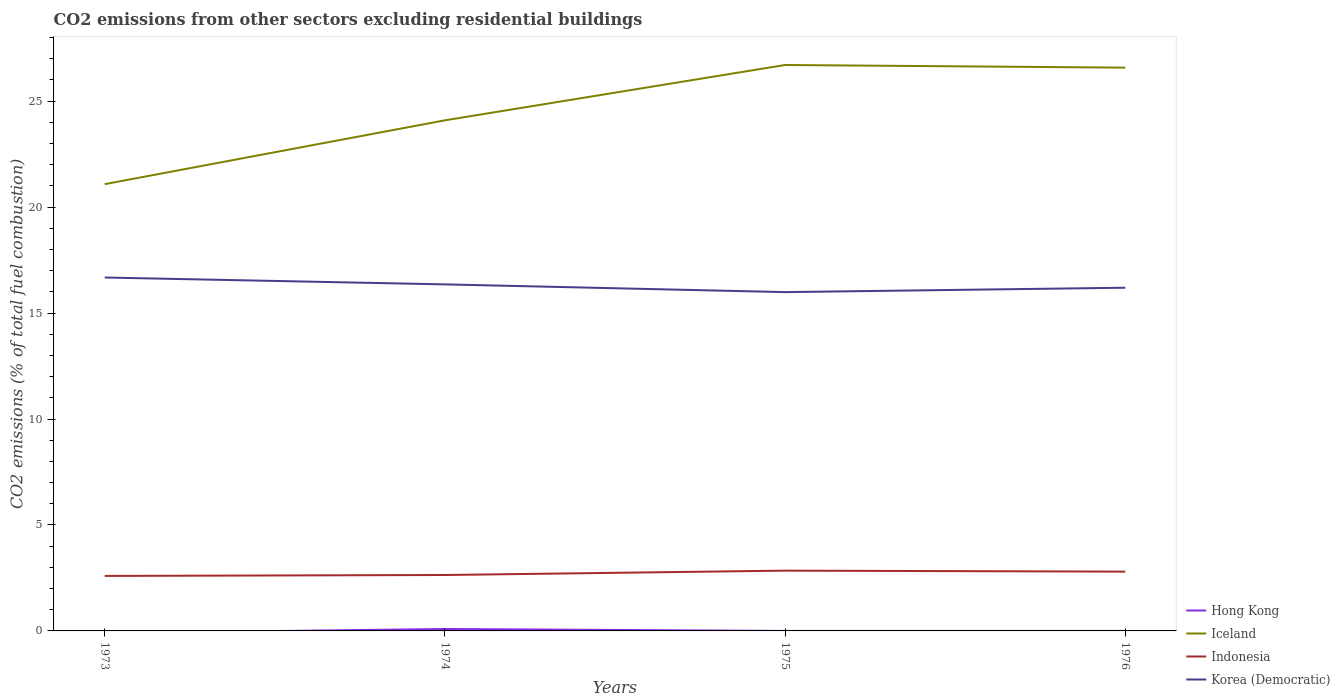How many different coloured lines are there?
Give a very brief answer. 4. Does the line corresponding to Korea (Democratic) intersect with the line corresponding to Iceland?
Offer a very short reply. No. Is the number of lines equal to the number of legend labels?
Provide a short and direct response. No. Across all years, what is the maximum total CO2 emitted in Iceland?
Your answer should be very brief. 21.08. What is the total total CO2 emitted in Indonesia in the graph?
Your answer should be very brief. -0.16. What is the difference between the highest and the second highest total CO2 emitted in Iceland?
Ensure brevity in your answer.  5.62. What is the difference between the highest and the lowest total CO2 emitted in Indonesia?
Offer a very short reply. 2. Is the total CO2 emitted in Iceland strictly greater than the total CO2 emitted in Hong Kong over the years?
Offer a very short reply. No. How many lines are there?
Offer a very short reply. 4. Does the graph contain any zero values?
Make the answer very short. Yes. Where does the legend appear in the graph?
Offer a terse response. Bottom right. How many legend labels are there?
Provide a short and direct response. 4. How are the legend labels stacked?
Make the answer very short. Vertical. What is the title of the graph?
Your response must be concise. CO2 emissions from other sectors excluding residential buildings. What is the label or title of the Y-axis?
Your answer should be compact. CO2 emissions (% of total fuel combustion). What is the CO2 emissions (% of total fuel combustion) in Iceland in 1973?
Your response must be concise. 21.08. What is the CO2 emissions (% of total fuel combustion) of Indonesia in 1973?
Your response must be concise. 2.6. What is the CO2 emissions (% of total fuel combustion) in Korea (Democratic) in 1973?
Your answer should be compact. 16.68. What is the CO2 emissions (% of total fuel combustion) in Hong Kong in 1974?
Offer a terse response. 0.09. What is the CO2 emissions (% of total fuel combustion) in Iceland in 1974?
Your answer should be compact. 24.1. What is the CO2 emissions (% of total fuel combustion) in Indonesia in 1974?
Keep it short and to the point. 2.64. What is the CO2 emissions (% of total fuel combustion) in Korea (Democratic) in 1974?
Give a very brief answer. 16.35. What is the CO2 emissions (% of total fuel combustion) of Hong Kong in 1975?
Provide a short and direct response. 5.135166626388329e-16. What is the CO2 emissions (% of total fuel combustion) in Iceland in 1975?
Provide a succinct answer. 26.71. What is the CO2 emissions (% of total fuel combustion) in Indonesia in 1975?
Your answer should be compact. 2.85. What is the CO2 emissions (% of total fuel combustion) in Korea (Democratic) in 1975?
Offer a very short reply. 15.99. What is the CO2 emissions (% of total fuel combustion) of Iceland in 1976?
Provide a succinct answer. 26.58. What is the CO2 emissions (% of total fuel combustion) in Indonesia in 1976?
Your response must be concise. 2.8. What is the CO2 emissions (% of total fuel combustion) of Korea (Democratic) in 1976?
Your response must be concise. 16.2. Across all years, what is the maximum CO2 emissions (% of total fuel combustion) of Hong Kong?
Make the answer very short. 0.09. Across all years, what is the maximum CO2 emissions (% of total fuel combustion) of Iceland?
Ensure brevity in your answer.  26.71. Across all years, what is the maximum CO2 emissions (% of total fuel combustion) of Indonesia?
Ensure brevity in your answer.  2.85. Across all years, what is the maximum CO2 emissions (% of total fuel combustion) of Korea (Democratic)?
Your answer should be very brief. 16.68. Across all years, what is the minimum CO2 emissions (% of total fuel combustion) of Hong Kong?
Your answer should be very brief. 0. Across all years, what is the minimum CO2 emissions (% of total fuel combustion) of Iceland?
Your answer should be very brief. 21.08. Across all years, what is the minimum CO2 emissions (% of total fuel combustion) in Indonesia?
Make the answer very short. 2.6. Across all years, what is the minimum CO2 emissions (% of total fuel combustion) in Korea (Democratic)?
Make the answer very short. 15.99. What is the total CO2 emissions (% of total fuel combustion) of Hong Kong in the graph?
Your response must be concise. 0.09. What is the total CO2 emissions (% of total fuel combustion) in Iceland in the graph?
Keep it short and to the point. 98.47. What is the total CO2 emissions (% of total fuel combustion) of Indonesia in the graph?
Offer a terse response. 10.88. What is the total CO2 emissions (% of total fuel combustion) of Korea (Democratic) in the graph?
Offer a very short reply. 65.22. What is the difference between the CO2 emissions (% of total fuel combustion) in Iceland in 1973 and that in 1974?
Offer a terse response. -3.01. What is the difference between the CO2 emissions (% of total fuel combustion) in Indonesia in 1973 and that in 1974?
Your answer should be very brief. -0.04. What is the difference between the CO2 emissions (% of total fuel combustion) of Korea (Democratic) in 1973 and that in 1974?
Offer a terse response. 0.32. What is the difference between the CO2 emissions (% of total fuel combustion) of Iceland in 1973 and that in 1975?
Provide a succinct answer. -5.62. What is the difference between the CO2 emissions (% of total fuel combustion) in Indonesia in 1973 and that in 1975?
Provide a short and direct response. -0.25. What is the difference between the CO2 emissions (% of total fuel combustion) of Korea (Democratic) in 1973 and that in 1975?
Offer a terse response. 0.69. What is the difference between the CO2 emissions (% of total fuel combustion) in Iceland in 1973 and that in 1976?
Offer a terse response. -5.5. What is the difference between the CO2 emissions (% of total fuel combustion) of Indonesia in 1973 and that in 1976?
Give a very brief answer. -0.2. What is the difference between the CO2 emissions (% of total fuel combustion) of Korea (Democratic) in 1973 and that in 1976?
Your answer should be compact. 0.48. What is the difference between the CO2 emissions (% of total fuel combustion) in Hong Kong in 1974 and that in 1975?
Offer a terse response. 0.09. What is the difference between the CO2 emissions (% of total fuel combustion) in Iceland in 1974 and that in 1975?
Keep it short and to the point. -2.61. What is the difference between the CO2 emissions (% of total fuel combustion) in Indonesia in 1974 and that in 1975?
Make the answer very short. -0.21. What is the difference between the CO2 emissions (% of total fuel combustion) of Korea (Democratic) in 1974 and that in 1975?
Keep it short and to the point. 0.36. What is the difference between the CO2 emissions (% of total fuel combustion) in Iceland in 1974 and that in 1976?
Your answer should be very brief. -2.49. What is the difference between the CO2 emissions (% of total fuel combustion) in Indonesia in 1974 and that in 1976?
Offer a terse response. -0.16. What is the difference between the CO2 emissions (% of total fuel combustion) of Korea (Democratic) in 1974 and that in 1976?
Provide a succinct answer. 0.16. What is the difference between the CO2 emissions (% of total fuel combustion) of Iceland in 1975 and that in 1976?
Provide a short and direct response. 0.13. What is the difference between the CO2 emissions (% of total fuel combustion) in Indonesia in 1975 and that in 1976?
Your answer should be very brief. 0.05. What is the difference between the CO2 emissions (% of total fuel combustion) of Korea (Democratic) in 1975 and that in 1976?
Provide a succinct answer. -0.21. What is the difference between the CO2 emissions (% of total fuel combustion) in Iceland in 1973 and the CO2 emissions (% of total fuel combustion) in Indonesia in 1974?
Provide a short and direct response. 18.45. What is the difference between the CO2 emissions (% of total fuel combustion) in Iceland in 1973 and the CO2 emissions (% of total fuel combustion) in Korea (Democratic) in 1974?
Ensure brevity in your answer.  4.73. What is the difference between the CO2 emissions (% of total fuel combustion) of Indonesia in 1973 and the CO2 emissions (% of total fuel combustion) of Korea (Democratic) in 1974?
Offer a very short reply. -13.76. What is the difference between the CO2 emissions (% of total fuel combustion) of Iceland in 1973 and the CO2 emissions (% of total fuel combustion) of Indonesia in 1975?
Offer a terse response. 18.24. What is the difference between the CO2 emissions (% of total fuel combustion) in Iceland in 1973 and the CO2 emissions (% of total fuel combustion) in Korea (Democratic) in 1975?
Make the answer very short. 5.1. What is the difference between the CO2 emissions (% of total fuel combustion) of Indonesia in 1973 and the CO2 emissions (% of total fuel combustion) of Korea (Democratic) in 1975?
Give a very brief answer. -13.39. What is the difference between the CO2 emissions (% of total fuel combustion) in Iceland in 1973 and the CO2 emissions (% of total fuel combustion) in Indonesia in 1976?
Your answer should be compact. 18.29. What is the difference between the CO2 emissions (% of total fuel combustion) of Iceland in 1973 and the CO2 emissions (% of total fuel combustion) of Korea (Democratic) in 1976?
Keep it short and to the point. 4.89. What is the difference between the CO2 emissions (% of total fuel combustion) in Indonesia in 1973 and the CO2 emissions (% of total fuel combustion) in Korea (Democratic) in 1976?
Your answer should be compact. -13.6. What is the difference between the CO2 emissions (% of total fuel combustion) in Hong Kong in 1974 and the CO2 emissions (% of total fuel combustion) in Iceland in 1975?
Your answer should be compact. -26.62. What is the difference between the CO2 emissions (% of total fuel combustion) of Hong Kong in 1974 and the CO2 emissions (% of total fuel combustion) of Indonesia in 1975?
Offer a very short reply. -2.75. What is the difference between the CO2 emissions (% of total fuel combustion) in Hong Kong in 1974 and the CO2 emissions (% of total fuel combustion) in Korea (Democratic) in 1975?
Offer a very short reply. -15.9. What is the difference between the CO2 emissions (% of total fuel combustion) of Iceland in 1974 and the CO2 emissions (% of total fuel combustion) of Indonesia in 1975?
Give a very brief answer. 21.25. What is the difference between the CO2 emissions (% of total fuel combustion) in Iceland in 1974 and the CO2 emissions (% of total fuel combustion) in Korea (Democratic) in 1975?
Provide a short and direct response. 8.11. What is the difference between the CO2 emissions (% of total fuel combustion) in Indonesia in 1974 and the CO2 emissions (% of total fuel combustion) in Korea (Democratic) in 1975?
Provide a short and direct response. -13.35. What is the difference between the CO2 emissions (% of total fuel combustion) in Hong Kong in 1974 and the CO2 emissions (% of total fuel combustion) in Iceland in 1976?
Your answer should be very brief. -26.49. What is the difference between the CO2 emissions (% of total fuel combustion) of Hong Kong in 1974 and the CO2 emissions (% of total fuel combustion) of Indonesia in 1976?
Provide a short and direct response. -2.71. What is the difference between the CO2 emissions (% of total fuel combustion) in Hong Kong in 1974 and the CO2 emissions (% of total fuel combustion) in Korea (Democratic) in 1976?
Your response must be concise. -16.11. What is the difference between the CO2 emissions (% of total fuel combustion) in Iceland in 1974 and the CO2 emissions (% of total fuel combustion) in Indonesia in 1976?
Your answer should be compact. 21.3. What is the difference between the CO2 emissions (% of total fuel combustion) in Iceland in 1974 and the CO2 emissions (% of total fuel combustion) in Korea (Democratic) in 1976?
Your answer should be very brief. 7.9. What is the difference between the CO2 emissions (% of total fuel combustion) in Indonesia in 1974 and the CO2 emissions (% of total fuel combustion) in Korea (Democratic) in 1976?
Provide a succinct answer. -13.56. What is the difference between the CO2 emissions (% of total fuel combustion) of Hong Kong in 1975 and the CO2 emissions (% of total fuel combustion) of Iceland in 1976?
Provide a succinct answer. -26.58. What is the difference between the CO2 emissions (% of total fuel combustion) in Hong Kong in 1975 and the CO2 emissions (% of total fuel combustion) in Indonesia in 1976?
Keep it short and to the point. -2.8. What is the difference between the CO2 emissions (% of total fuel combustion) of Hong Kong in 1975 and the CO2 emissions (% of total fuel combustion) of Korea (Democratic) in 1976?
Your answer should be very brief. -16.2. What is the difference between the CO2 emissions (% of total fuel combustion) in Iceland in 1975 and the CO2 emissions (% of total fuel combustion) in Indonesia in 1976?
Keep it short and to the point. 23.91. What is the difference between the CO2 emissions (% of total fuel combustion) in Iceland in 1975 and the CO2 emissions (% of total fuel combustion) in Korea (Democratic) in 1976?
Make the answer very short. 10.51. What is the difference between the CO2 emissions (% of total fuel combustion) in Indonesia in 1975 and the CO2 emissions (% of total fuel combustion) in Korea (Democratic) in 1976?
Provide a succinct answer. -13.35. What is the average CO2 emissions (% of total fuel combustion) of Hong Kong per year?
Make the answer very short. 0.02. What is the average CO2 emissions (% of total fuel combustion) of Iceland per year?
Make the answer very short. 24.62. What is the average CO2 emissions (% of total fuel combustion) of Indonesia per year?
Give a very brief answer. 2.72. What is the average CO2 emissions (% of total fuel combustion) of Korea (Democratic) per year?
Make the answer very short. 16.3. In the year 1973, what is the difference between the CO2 emissions (% of total fuel combustion) in Iceland and CO2 emissions (% of total fuel combustion) in Indonesia?
Keep it short and to the point. 18.49. In the year 1973, what is the difference between the CO2 emissions (% of total fuel combustion) of Iceland and CO2 emissions (% of total fuel combustion) of Korea (Democratic)?
Your response must be concise. 4.41. In the year 1973, what is the difference between the CO2 emissions (% of total fuel combustion) of Indonesia and CO2 emissions (% of total fuel combustion) of Korea (Democratic)?
Keep it short and to the point. -14.08. In the year 1974, what is the difference between the CO2 emissions (% of total fuel combustion) in Hong Kong and CO2 emissions (% of total fuel combustion) in Iceland?
Give a very brief answer. -24.01. In the year 1974, what is the difference between the CO2 emissions (% of total fuel combustion) in Hong Kong and CO2 emissions (% of total fuel combustion) in Indonesia?
Give a very brief answer. -2.55. In the year 1974, what is the difference between the CO2 emissions (% of total fuel combustion) of Hong Kong and CO2 emissions (% of total fuel combustion) of Korea (Democratic)?
Your answer should be compact. -16.26. In the year 1974, what is the difference between the CO2 emissions (% of total fuel combustion) in Iceland and CO2 emissions (% of total fuel combustion) in Indonesia?
Offer a terse response. 21.46. In the year 1974, what is the difference between the CO2 emissions (% of total fuel combustion) of Iceland and CO2 emissions (% of total fuel combustion) of Korea (Democratic)?
Offer a very short reply. 7.74. In the year 1974, what is the difference between the CO2 emissions (% of total fuel combustion) of Indonesia and CO2 emissions (% of total fuel combustion) of Korea (Democratic)?
Your answer should be very brief. -13.71. In the year 1975, what is the difference between the CO2 emissions (% of total fuel combustion) in Hong Kong and CO2 emissions (% of total fuel combustion) in Iceland?
Make the answer very short. -26.71. In the year 1975, what is the difference between the CO2 emissions (% of total fuel combustion) of Hong Kong and CO2 emissions (% of total fuel combustion) of Indonesia?
Provide a succinct answer. -2.85. In the year 1975, what is the difference between the CO2 emissions (% of total fuel combustion) of Hong Kong and CO2 emissions (% of total fuel combustion) of Korea (Democratic)?
Make the answer very short. -15.99. In the year 1975, what is the difference between the CO2 emissions (% of total fuel combustion) of Iceland and CO2 emissions (% of total fuel combustion) of Indonesia?
Your response must be concise. 23.86. In the year 1975, what is the difference between the CO2 emissions (% of total fuel combustion) in Iceland and CO2 emissions (% of total fuel combustion) in Korea (Democratic)?
Your answer should be compact. 10.72. In the year 1975, what is the difference between the CO2 emissions (% of total fuel combustion) of Indonesia and CO2 emissions (% of total fuel combustion) of Korea (Democratic)?
Provide a short and direct response. -13.14. In the year 1976, what is the difference between the CO2 emissions (% of total fuel combustion) in Iceland and CO2 emissions (% of total fuel combustion) in Indonesia?
Ensure brevity in your answer.  23.78. In the year 1976, what is the difference between the CO2 emissions (% of total fuel combustion) of Iceland and CO2 emissions (% of total fuel combustion) of Korea (Democratic)?
Your answer should be compact. 10.39. In the year 1976, what is the difference between the CO2 emissions (% of total fuel combustion) of Indonesia and CO2 emissions (% of total fuel combustion) of Korea (Democratic)?
Make the answer very short. -13.4. What is the ratio of the CO2 emissions (% of total fuel combustion) of Iceland in 1973 to that in 1974?
Offer a terse response. 0.88. What is the ratio of the CO2 emissions (% of total fuel combustion) in Indonesia in 1973 to that in 1974?
Your answer should be very brief. 0.98. What is the ratio of the CO2 emissions (% of total fuel combustion) of Korea (Democratic) in 1973 to that in 1974?
Ensure brevity in your answer.  1.02. What is the ratio of the CO2 emissions (% of total fuel combustion) of Iceland in 1973 to that in 1975?
Your answer should be compact. 0.79. What is the ratio of the CO2 emissions (% of total fuel combustion) in Indonesia in 1973 to that in 1975?
Provide a succinct answer. 0.91. What is the ratio of the CO2 emissions (% of total fuel combustion) of Korea (Democratic) in 1973 to that in 1975?
Make the answer very short. 1.04. What is the ratio of the CO2 emissions (% of total fuel combustion) in Iceland in 1973 to that in 1976?
Make the answer very short. 0.79. What is the ratio of the CO2 emissions (% of total fuel combustion) of Indonesia in 1973 to that in 1976?
Your answer should be compact. 0.93. What is the ratio of the CO2 emissions (% of total fuel combustion) in Korea (Democratic) in 1973 to that in 1976?
Ensure brevity in your answer.  1.03. What is the ratio of the CO2 emissions (% of total fuel combustion) of Hong Kong in 1974 to that in 1975?
Keep it short and to the point. 1.78e+14. What is the ratio of the CO2 emissions (% of total fuel combustion) of Iceland in 1974 to that in 1975?
Ensure brevity in your answer.  0.9. What is the ratio of the CO2 emissions (% of total fuel combustion) of Indonesia in 1974 to that in 1975?
Keep it short and to the point. 0.93. What is the ratio of the CO2 emissions (% of total fuel combustion) of Korea (Democratic) in 1974 to that in 1975?
Your response must be concise. 1.02. What is the ratio of the CO2 emissions (% of total fuel combustion) of Iceland in 1974 to that in 1976?
Offer a terse response. 0.91. What is the ratio of the CO2 emissions (% of total fuel combustion) of Indonesia in 1974 to that in 1976?
Make the answer very short. 0.94. What is the ratio of the CO2 emissions (% of total fuel combustion) in Korea (Democratic) in 1974 to that in 1976?
Your answer should be compact. 1.01. What is the ratio of the CO2 emissions (% of total fuel combustion) of Iceland in 1975 to that in 1976?
Ensure brevity in your answer.  1. What is the ratio of the CO2 emissions (% of total fuel combustion) of Indonesia in 1975 to that in 1976?
Your answer should be compact. 1.02. What is the ratio of the CO2 emissions (% of total fuel combustion) in Korea (Democratic) in 1975 to that in 1976?
Give a very brief answer. 0.99. What is the difference between the highest and the second highest CO2 emissions (% of total fuel combustion) in Iceland?
Make the answer very short. 0.13. What is the difference between the highest and the second highest CO2 emissions (% of total fuel combustion) of Indonesia?
Give a very brief answer. 0.05. What is the difference between the highest and the second highest CO2 emissions (% of total fuel combustion) in Korea (Democratic)?
Give a very brief answer. 0.32. What is the difference between the highest and the lowest CO2 emissions (% of total fuel combustion) of Hong Kong?
Your answer should be compact. 0.09. What is the difference between the highest and the lowest CO2 emissions (% of total fuel combustion) in Iceland?
Your answer should be compact. 5.62. What is the difference between the highest and the lowest CO2 emissions (% of total fuel combustion) of Indonesia?
Offer a terse response. 0.25. What is the difference between the highest and the lowest CO2 emissions (% of total fuel combustion) of Korea (Democratic)?
Give a very brief answer. 0.69. 